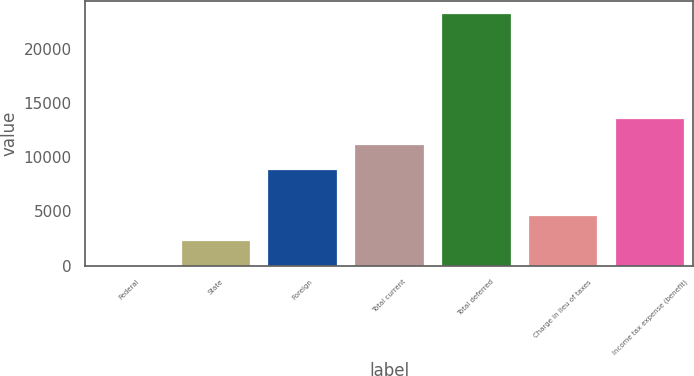<chart> <loc_0><loc_0><loc_500><loc_500><bar_chart><fcel>Federal<fcel>State<fcel>Foreign<fcel>Total current<fcel>Total deferred<fcel>Charge in lieu of taxes<fcel>Income tax expense (benefit)<nl><fcel>31<fcel>2355.6<fcel>8923<fcel>11247.6<fcel>23277<fcel>4680.2<fcel>13572.2<nl></chart> 